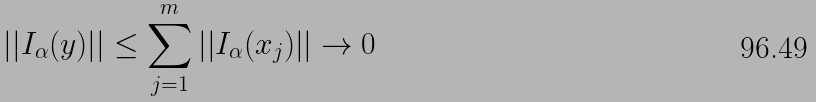<formula> <loc_0><loc_0><loc_500><loc_500>\left | \left | I _ { \alpha } ( y ) \right | \right | \leq \sum _ { j = 1 } ^ { m } \left | \left | I _ { \alpha } ( x _ { j } ) \right | \right | \rightarrow 0</formula> 